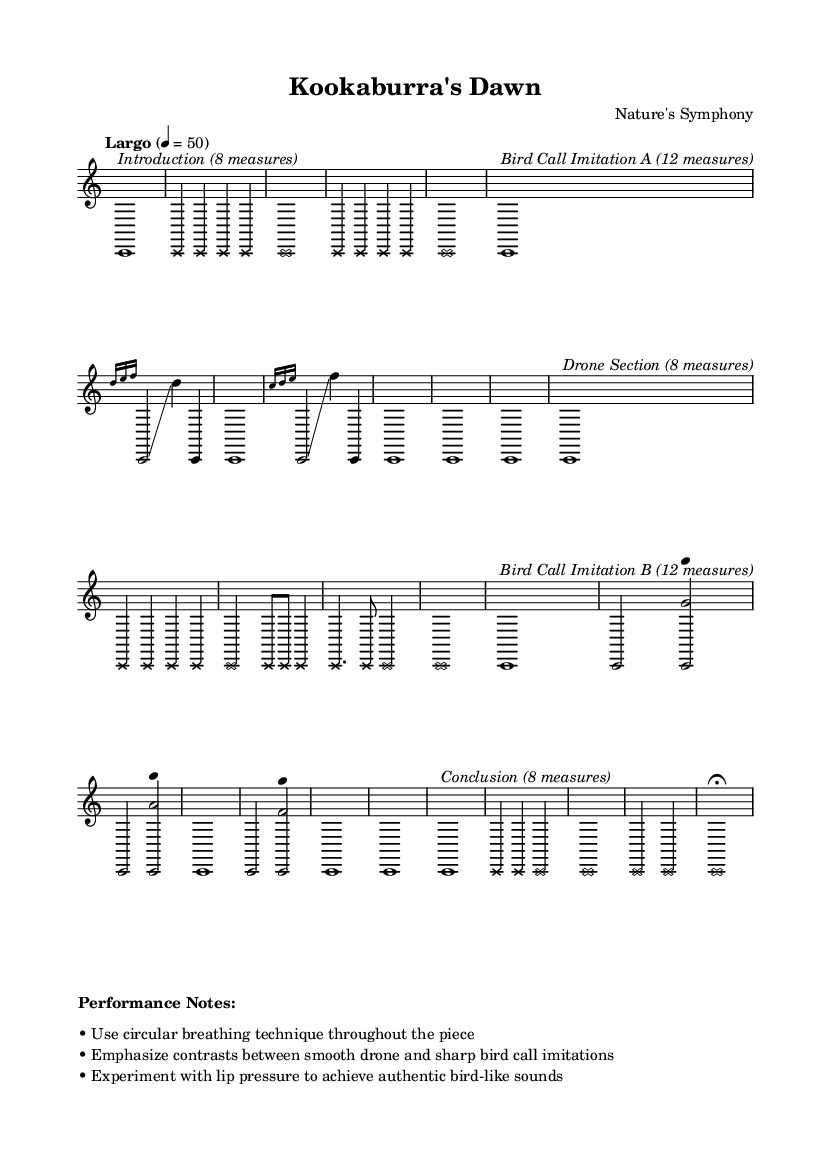What is the tempo of this piece? The tempo is marked as "Largo" with a metronome marking of 4 = 50, indicating a slow pace.
Answer: Largo, 4 = 50 How many measures are in the Bird Call Imitation A section? Looking at the sheet music, the Bird Call Imitation A section is marked to contain 12 measures, which is noted in the score.
Answer: 12 measures Which section contains the drone technique? The Drone Section is explicitly labeled in the sheet music, and according to the structure, it follows Bird Call Imitation A.
Answer: Drone Section What kind of breathing technique is suggested for the performance? The performance notes mention using circular breathing throughout the piece, which is essential for maintaining sound continuity.
Answer: Circular breathing How does the note style change between Bird Call and Drone sections? In Bird Call sections, the note style is default, while in the Drone Section, the note head style changes to cross, signifying a different texture or emphasis.
Answer: Cross What is the last section of the composition? The last section is labeled as the Conclusion, which is consistent with the common structure of musical compositions ending with a final segment.
Answer: Conclusion 